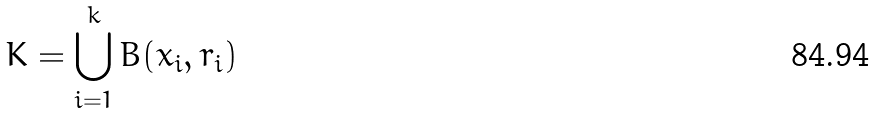Convert formula to latex. <formula><loc_0><loc_0><loc_500><loc_500>K = \bigcup _ { i = 1 } ^ { k } B ( x _ { i } , r _ { i } )</formula> 